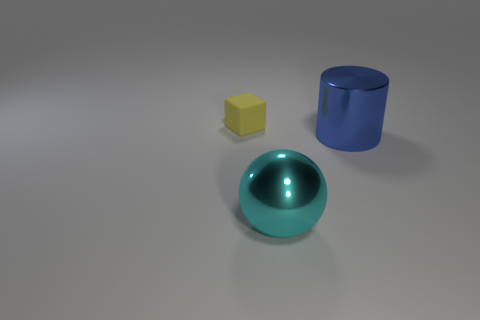How many things are left of the large cyan shiny sphere and to the right of the yellow matte block? There are no objects positioned to the left of the cyan shiny sphere and to the right of the yellow matte block. To clarify, the configuration of objects does not permit an item to be both left of the cyan sphere and right of the yellow block. 